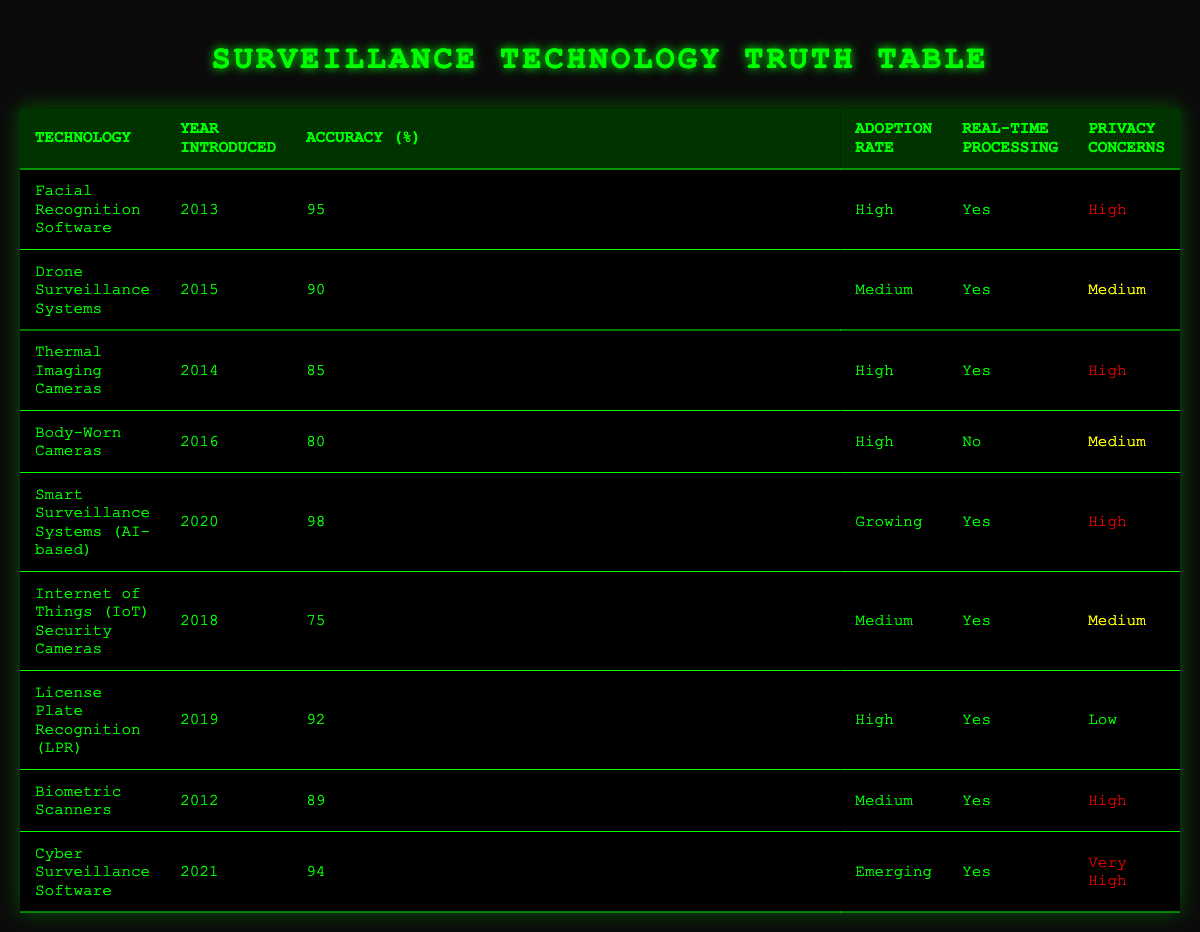What is the highest accuracy percentage among the surveillance technologies listed? The accuracy percentages in the table are 95, 90, 85, 80, 98, 75, 92, 89, and 94. Comparing these values, the highest accuracy percentage is 98.
Answer: 98 Which surveillance technology was introduced in 2018 and what is its accuracy percentage? From the data, the technology introduced in 2018 is the Internet of Things (IoT) Security Cameras, which has an accuracy percentage of 75.
Answer: Internet of Things (IoT) Security Cameras, 75 Is there any surveillance technology with a high adoption rate that has low privacy concerns? According to the table, the License Plate Recognition (LPR) technology has a high adoption rate and low privacy concerns. Thus, the answer is yes.
Answer: Yes What is the average accuracy percentage of the technologies introduced before 2016? The technologies introduced before 2016 are Facial Recognition Software (95), Thermal Imaging Cameras (85), and Biometric Scanners (89). To find the average, we sum these percentages: (95 + 85 + 89) = 269, and there are 3 technologies; thus, the average is 269/3 = 89.67, which rounds to 90 if considering integers.
Answer: 90 How many technologies have real-time processing capabilities and a high adoption rate? The technologies with real-time processing that also have a high adoption rate are Facial Recognition Software, Thermal Imaging Cameras, and License Plate Recognition (LPR), totaling three technologies.
Answer: 3 Which technology has emerged most recently and what are its privacy concerns? Cyber Surveillance Software was introduced in 2021, which is the most recent technology, and it has very high privacy concerns.
Answer: Cyber Surveillance Software, very high Are all technologies introduced in 2014 characterized by real-time processing? Examining the table, the only technology introduced in 2014 is Thermal Imaging Cameras, which does have real-time processing. So, the answer is yes.
Answer: Yes What is the difference in accuracy percentage between the highest and lowest accuracy technologies? The highest accuracy percentage is 98 (Smart Surveillance Systems), and the lowest is 75 (Internet of Things Security Cameras). The difference is 98 - 75 = 23.
Answer: 23 